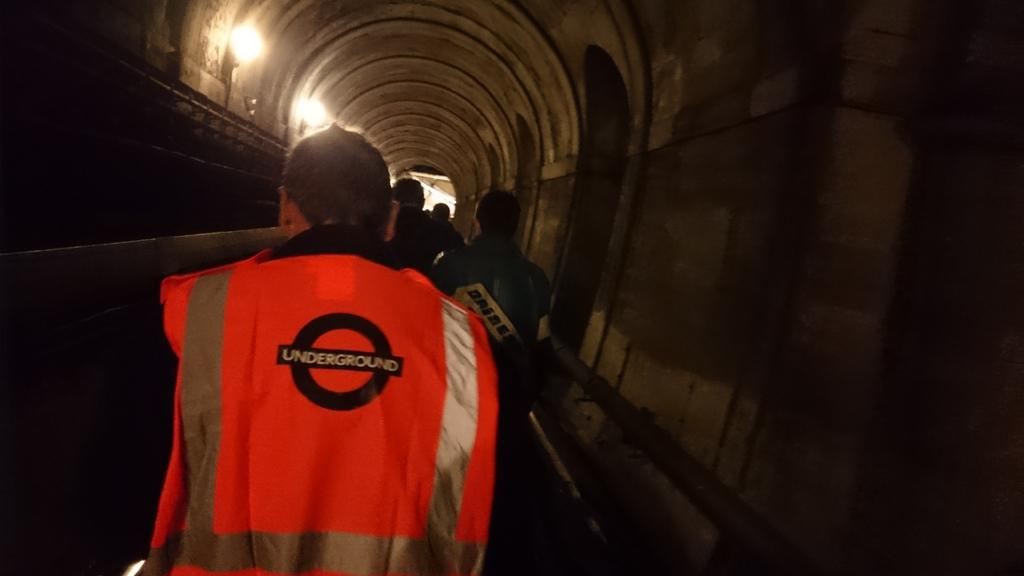<image>
Share a concise interpretation of the image provided. A man wearing an Underground vest walks with others in a tunnel. 